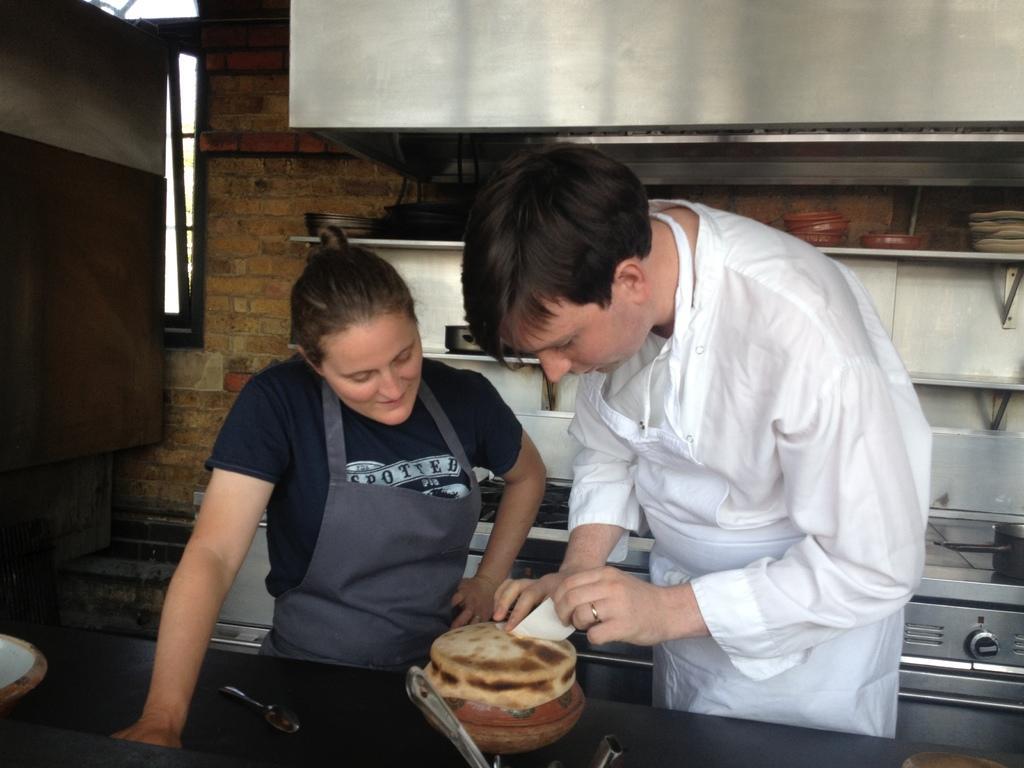Please provide a concise description of this image. In this image I can see two persons standing, the person at left is wearing black color dress and the person at right is wearing white color dress. In front I can see the food in cream and brown color, background I can see few plates in the racks and the wall is in brown color. 